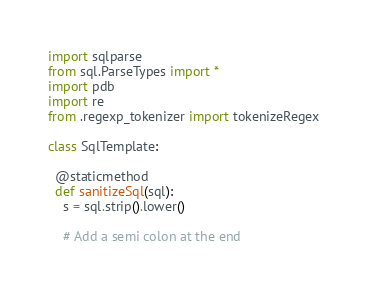Convert code to text. <code><loc_0><loc_0><loc_500><loc_500><_Python_>import sqlparse
from sql.ParseTypes import *
import pdb
import re
from .regexp_tokenizer import tokenizeRegex

class SqlTemplate:

  @staticmethod
  def sanitizeSql(sql):
    s = sql.strip().lower()

    # Add a semi colon at the end</code> 